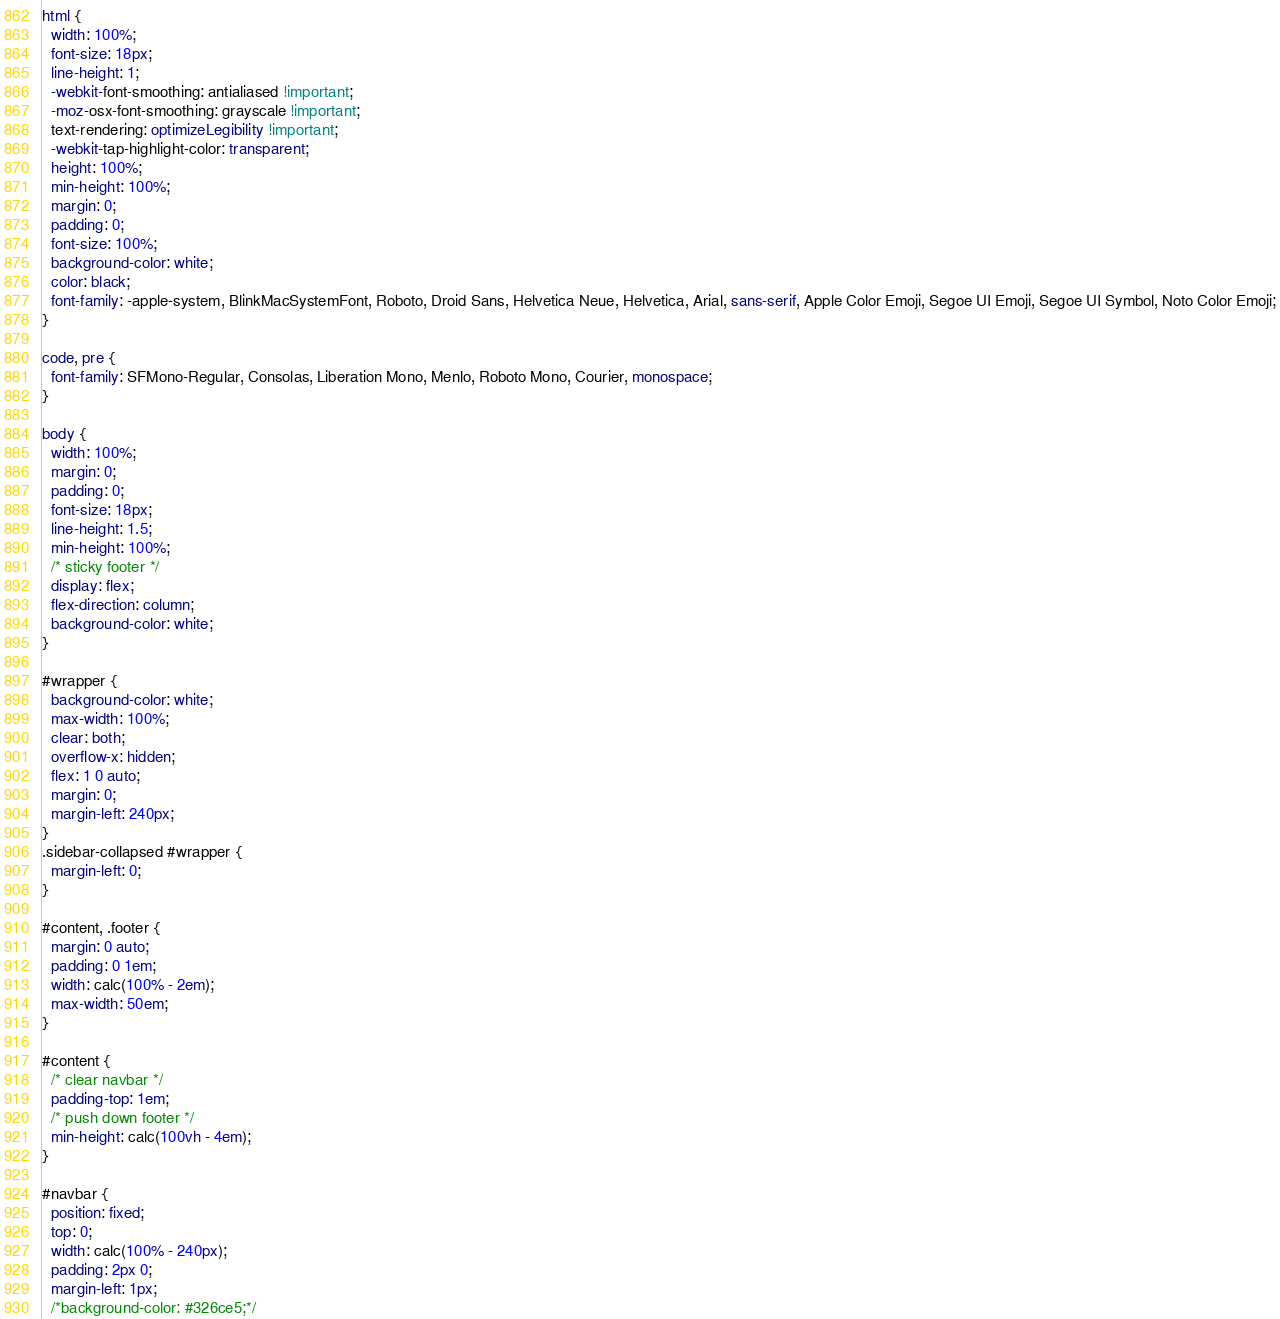<code> <loc_0><loc_0><loc_500><loc_500><_CSS_>html {
  width: 100%;
  font-size: 18px;
  line-height: 1;
  -webkit-font-smoothing: antialiased !important;
  -moz-osx-font-smoothing: grayscale !important;
  text-rendering: optimizeLegibility !important;
  -webkit-tap-highlight-color: transparent;
  height: 100%;
  min-height: 100%;
  margin: 0;
  padding: 0;
  font-size: 100%;
  background-color: white;
  color: black;
  font-family: -apple-system, BlinkMacSystemFont, Roboto, Droid Sans, Helvetica Neue, Helvetica, Arial, sans-serif, Apple Color Emoji, Segoe UI Emoji, Segoe UI Symbol, Noto Color Emoji;
}

code, pre {
  font-family: SFMono-Regular, Consolas, Liberation Mono, Menlo, Roboto Mono, Courier, monospace;
}

body {
  width: 100%;
  margin: 0;
  padding: 0;
  font-size: 18px;
  line-height: 1.5;
  min-height: 100%;
  /* sticky footer */
  display: flex;
  flex-direction: column;
  background-color: white;
}

#wrapper {
  background-color: white;
  max-width: 100%;
  clear: both;
  overflow-x: hidden;
  flex: 1 0 auto;
  margin: 0;
  margin-left: 240px;
}
.sidebar-collapsed #wrapper {
  margin-left: 0;
}

#content, .footer {
  margin: 0 auto;
  padding: 0 1em;
  width: calc(100% - 2em);
  max-width: 50em;
}

#content { 
  /* clear navbar */
  padding-top: 1em;
  /* push down footer */
  min-height: calc(100vh - 4em);
}

#navbar {
  position: fixed;
  top: 0;
  width: calc(100% - 240px);
  padding: 2px 0;
  margin-left: 1px;
  /*background-color: #326ce5;*/</code> 